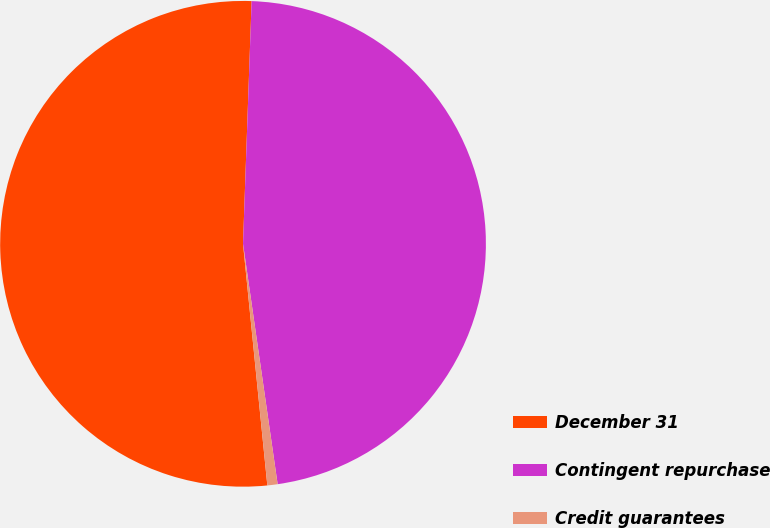Convert chart to OTSL. <chart><loc_0><loc_0><loc_500><loc_500><pie_chart><fcel>December 31<fcel>Contingent repurchase<fcel>Credit guarantees<nl><fcel>52.16%<fcel>47.16%<fcel>0.68%<nl></chart> 